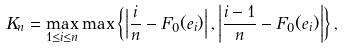<formula> <loc_0><loc_0><loc_500><loc_500>K _ { n } = \max _ { 1 \leq i \leq n } \max \left \{ \left | \frac { i } { n } - F _ { 0 } ( e _ { i } ) \right | , \left | \frac { i - 1 } { n } - F _ { 0 } ( e _ { i } ) \right | \right \} ,</formula> 